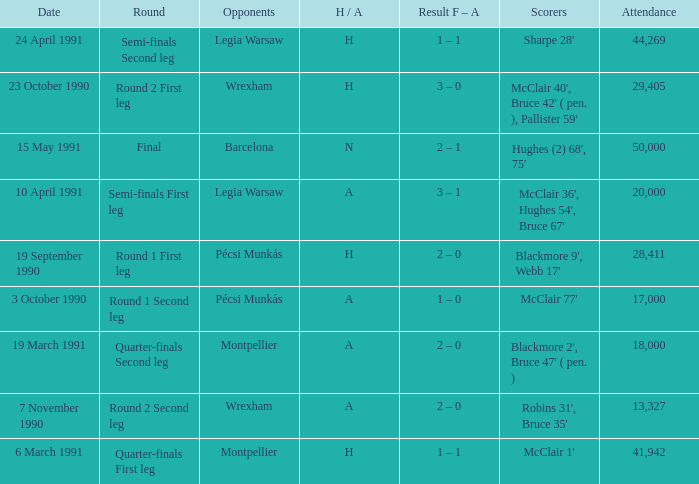What is the lowest attendance when the h/A is H in the Semi-Finals Second Leg? 44269.0. 